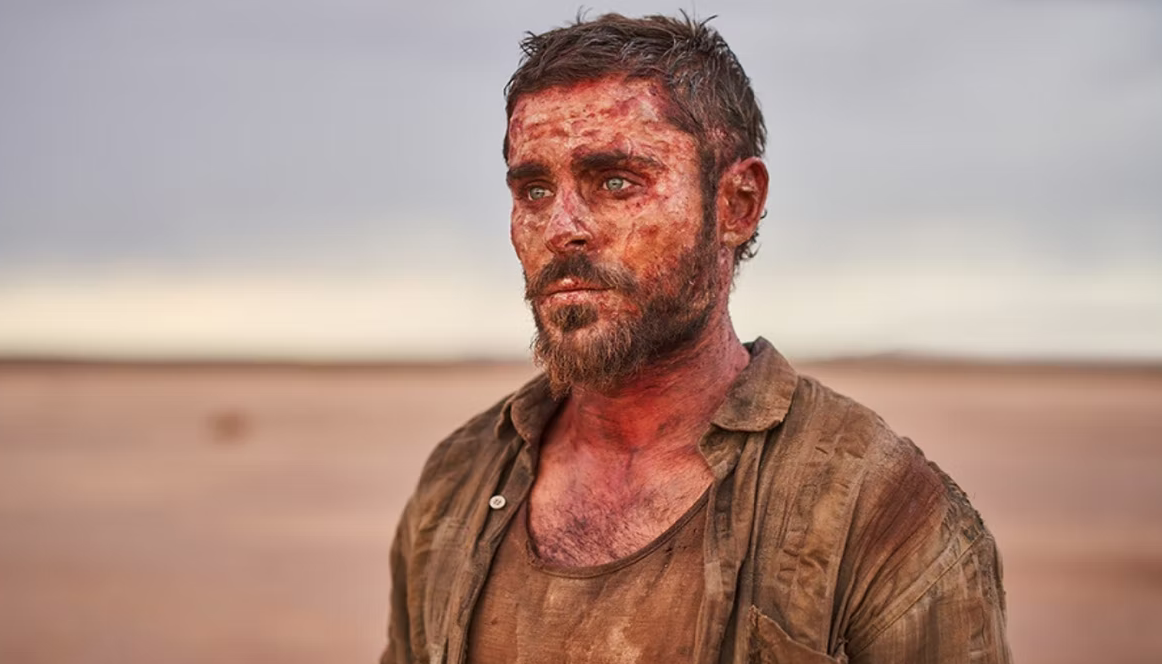Create a whimsical and unrealistic scenario involving this image. In a whimsical twist of fate, the character played by Zac Efron stumbles upon a hidden oasis in the middle of the desert. As he approaches, he finds a secret entrance to an underground city inhabited by friendly, talking meerkats. These meerkats, wearing tiny outfits reminiscent of ancient desert civilizations, welcome him with open arms. They provide him with magical elixirs to heal his wounds and ancient wisdom to navigate the desert's perils. In a fantastical turn of events, he becomes the king of this enchanted meerkat kingdom, leading adventurous expeditions to discover long-lost treasures buried beneath the sands. 